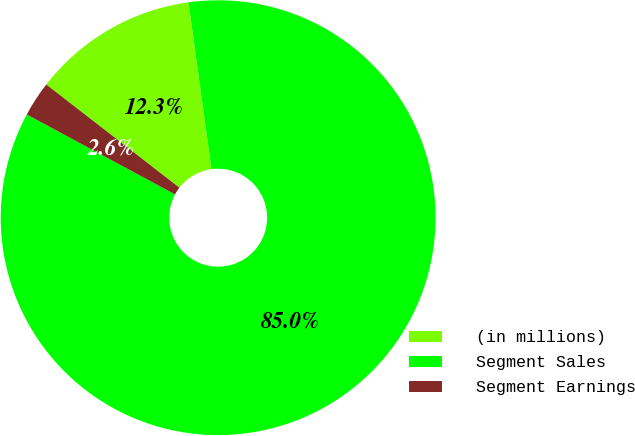Convert chart. <chart><loc_0><loc_0><loc_500><loc_500><pie_chart><fcel>(in millions)<fcel>Segment Sales<fcel>Segment Earnings<nl><fcel>12.33%<fcel>85.05%<fcel>2.62%<nl></chart> 